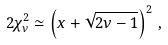<formula> <loc_0><loc_0><loc_500><loc_500>2 \chi ^ { 2 } _ { \nu } \simeq \left ( x + \sqrt { 2 \nu - 1 } \right ) ^ { 2 } \, ,</formula> 